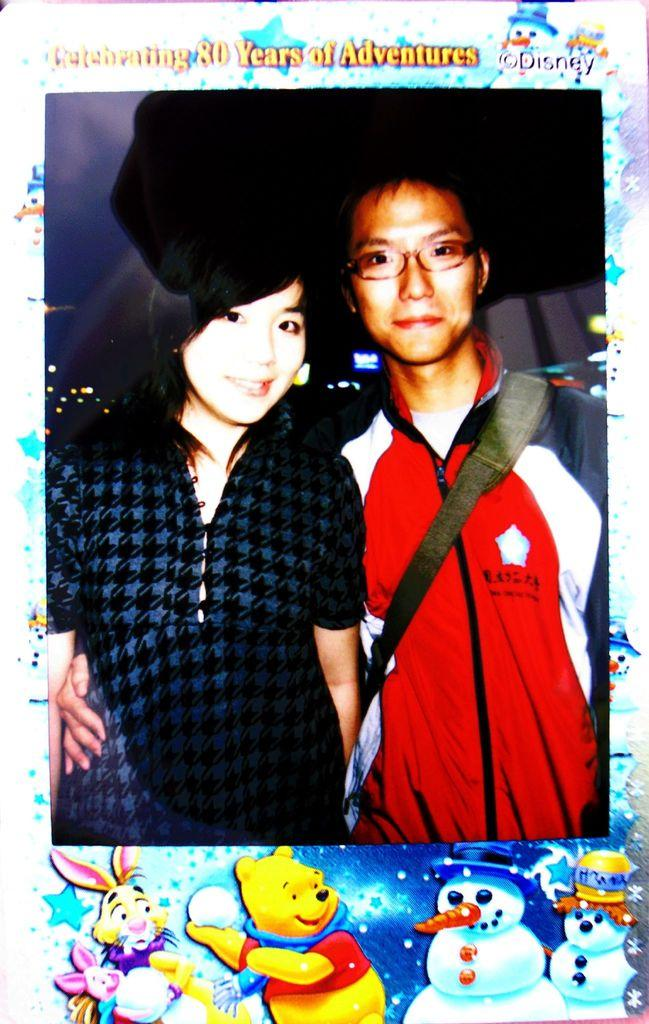What is the main subject of the image? The main subject of the image is a frame. What can be seen inside the frame? There is a couple in the frame. How are the couple positioned in the frame? The man is on the right side of the frame, and the girl is on the left side of the frame. What is the plot of the teaching session happening in the image? There is no teaching session or plot present in the image; it features a frame with a couple inside. Can you describe the squirrel that is sitting on the girl's shoulder in the image? There is no squirrel present in the image; it only features a couple inside the frame. 